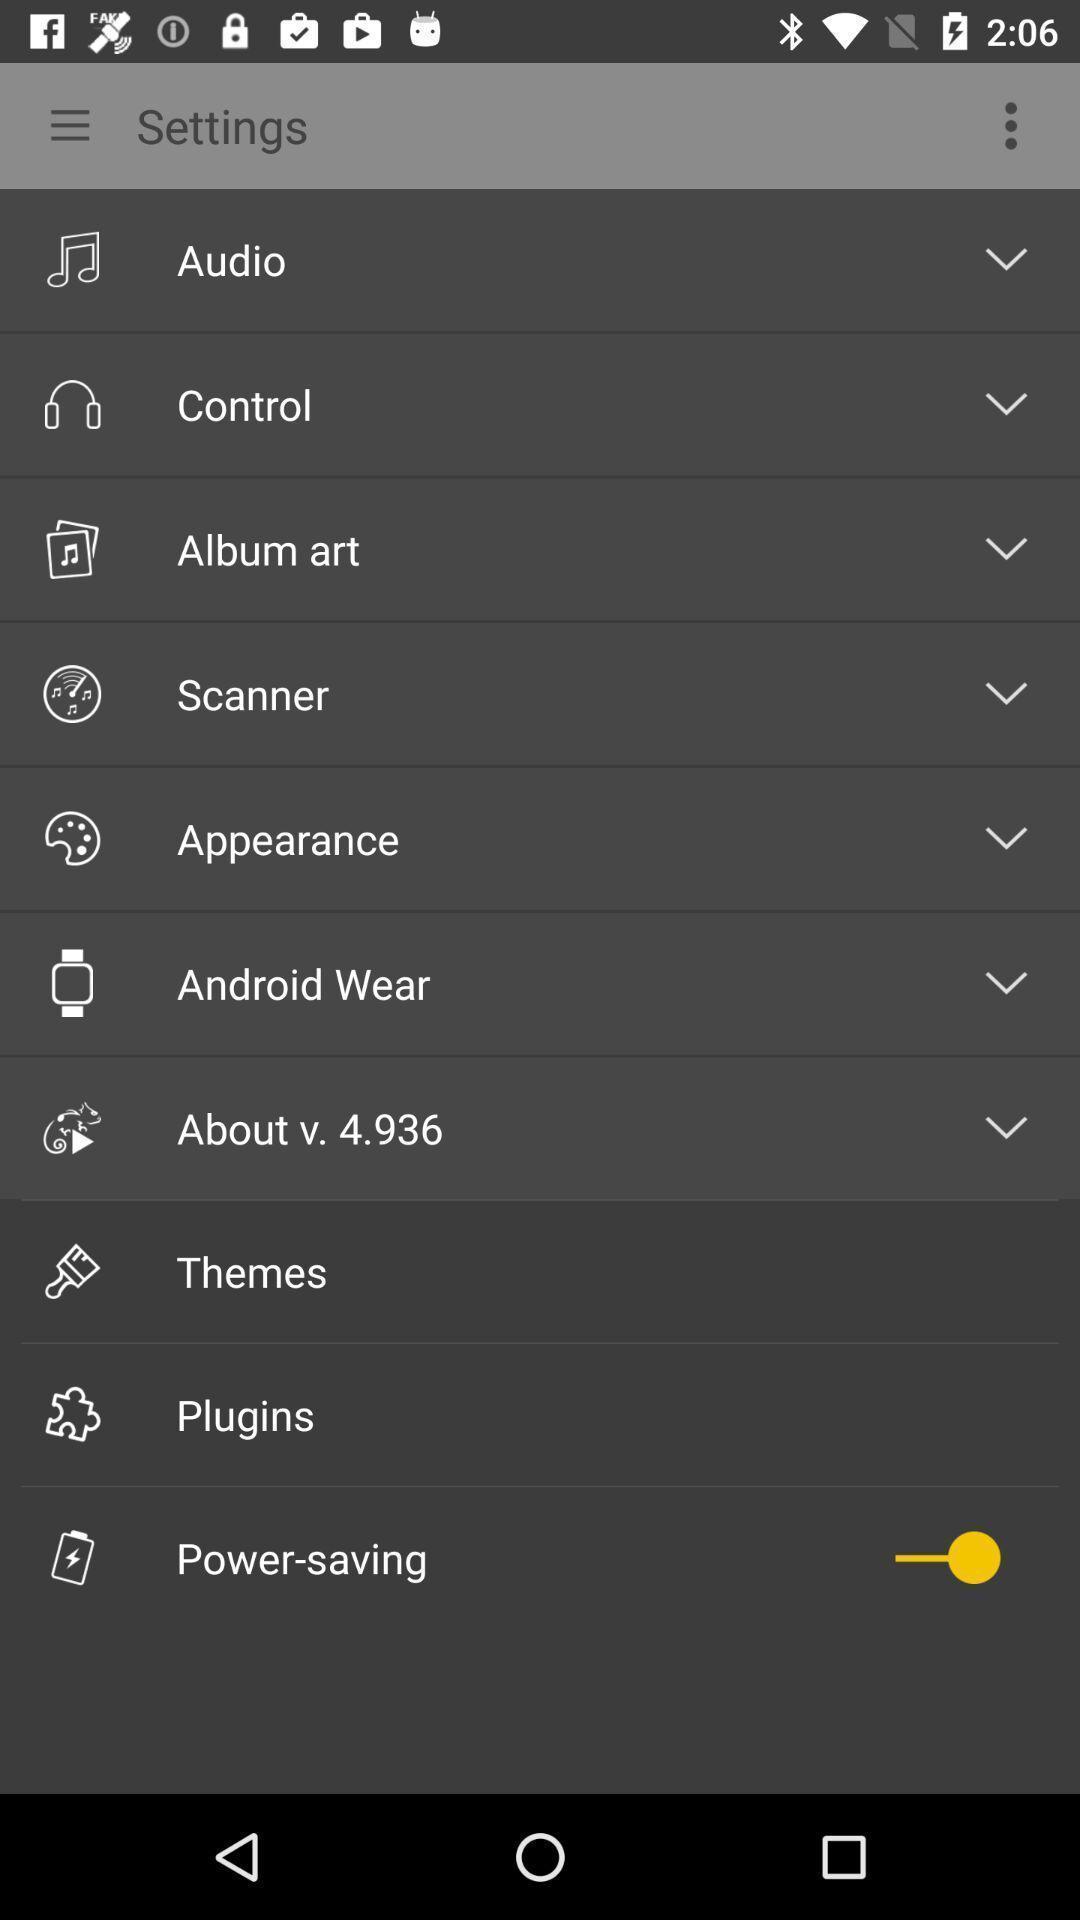Provide a textual representation of this image. Settings page of an online app. 